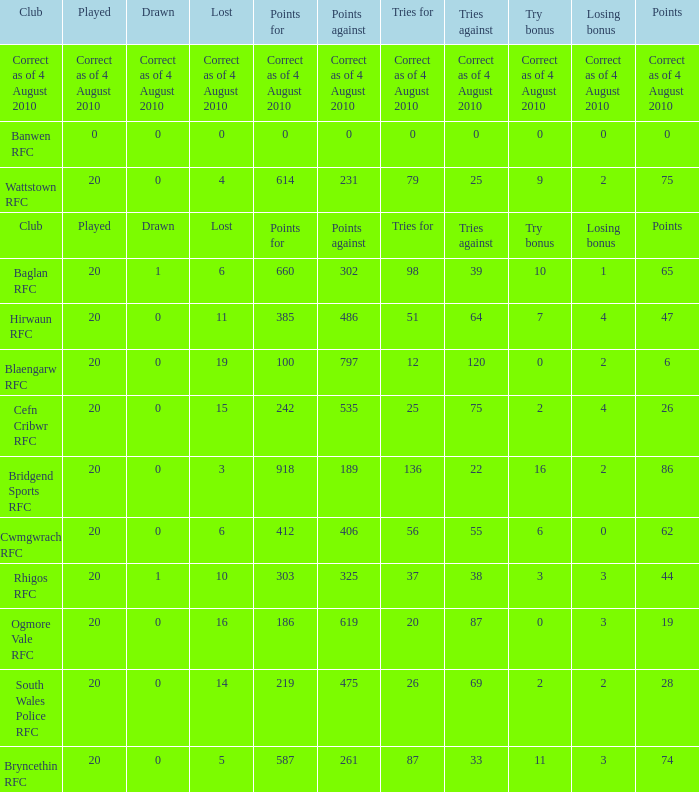What is the points against when drawn is drawn? Points against. 